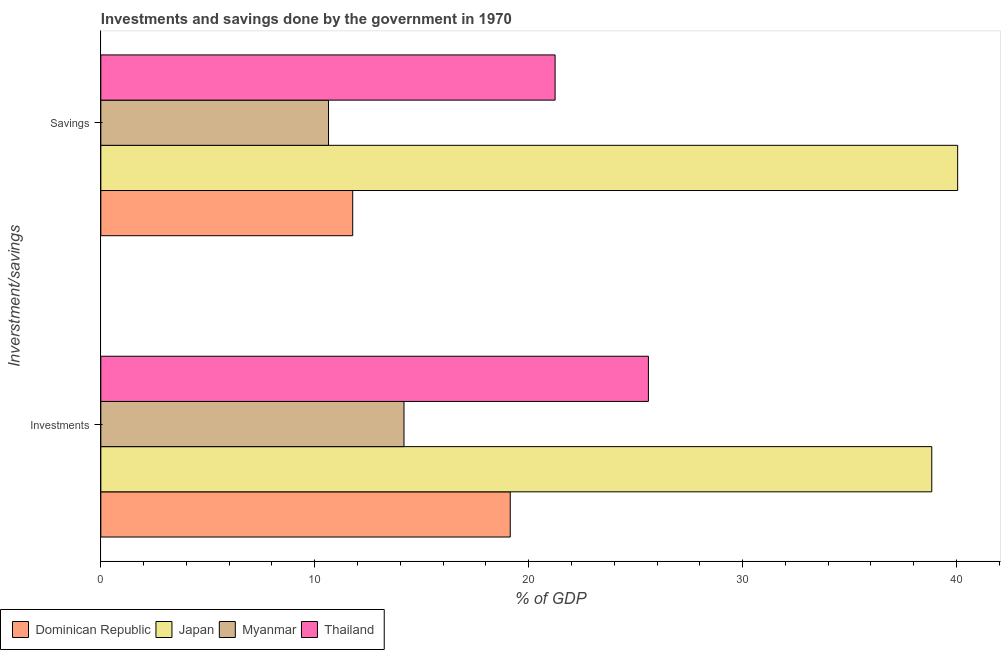How many different coloured bars are there?
Your response must be concise. 4. Are the number of bars on each tick of the Y-axis equal?
Ensure brevity in your answer.  Yes. How many bars are there on the 2nd tick from the bottom?
Offer a very short reply. 4. What is the label of the 2nd group of bars from the top?
Offer a terse response. Investments. What is the investments of government in Thailand?
Offer a very short reply. 25.6. Across all countries, what is the maximum investments of government?
Your answer should be compact. 38.84. Across all countries, what is the minimum investments of government?
Your answer should be compact. 14.17. In which country was the investments of government minimum?
Your answer should be compact. Myanmar. What is the total savings of government in the graph?
Give a very brief answer. 83.71. What is the difference between the investments of government in Japan and that in Myanmar?
Keep it short and to the point. 24.67. What is the difference between the savings of government in Myanmar and the investments of government in Dominican Republic?
Your answer should be compact. -8.5. What is the average savings of government per country?
Ensure brevity in your answer.  20.93. What is the difference between the savings of government and investments of government in Myanmar?
Provide a short and direct response. -3.53. In how many countries, is the savings of government greater than 12 %?
Give a very brief answer. 2. What is the ratio of the savings of government in Thailand to that in Japan?
Offer a terse response. 0.53. What does the 4th bar from the top in Investments represents?
Offer a terse response. Dominican Republic. What does the 3rd bar from the bottom in Investments represents?
Give a very brief answer. Myanmar. How many bars are there?
Provide a short and direct response. 8. Does the graph contain any zero values?
Your answer should be compact. No. How many legend labels are there?
Ensure brevity in your answer.  4. How are the legend labels stacked?
Make the answer very short. Horizontal. What is the title of the graph?
Offer a very short reply. Investments and savings done by the government in 1970. Does "Sao Tome and Principe" appear as one of the legend labels in the graph?
Your answer should be very brief. No. What is the label or title of the X-axis?
Your answer should be compact. % of GDP. What is the label or title of the Y-axis?
Your response must be concise. Inverstment/savings. What is the % of GDP of Dominican Republic in Investments?
Provide a short and direct response. 19.14. What is the % of GDP in Japan in Investments?
Offer a very short reply. 38.84. What is the % of GDP of Myanmar in Investments?
Provide a succinct answer. 14.17. What is the % of GDP in Thailand in Investments?
Offer a very short reply. 25.6. What is the % of GDP in Dominican Republic in Savings?
Make the answer very short. 11.77. What is the % of GDP of Japan in Savings?
Provide a succinct answer. 40.05. What is the % of GDP in Myanmar in Savings?
Your answer should be very brief. 10.64. What is the % of GDP of Thailand in Savings?
Provide a short and direct response. 21.24. Across all Inverstment/savings, what is the maximum % of GDP in Dominican Republic?
Ensure brevity in your answer.  19.14. Across all Inverstment/savings, what is the maximum % of GDP of Japan?
Ensure brevity in your answer.  40.05. Across all Inverstment/savings, what is the maximum % of GDP of Myanmar?
Give a very brief answer. 14.17. Across all Inverstment/savings, what is the maximum % of GDP of Thailand?
Ensure brevity in your answer.  25.6. Across all Inverstment/savings, what is the minimum % of GDP in Dominican Republic?
Your response must be concise. 11.77. Across all Inverstment/savings, what is the minimum % of GDP in Japan?
Ensure brevity in your answer.  38.84. Across all Inverstment/savings, what is the minimum % of GDP in Myanmar?
Provide a succinct answer. 10.64. Across all Inverstment/savings, what is the minimum % of GDP of Thailand?
Provide a succinct answer. 21.24. What is the total % of GDP of Dominican Republic in the graph?
Make the answer very short. 30.91. What is the total % of GDP in Japan in the graph?
Give a very brief answer. 78.9. What is the total % of GDP of Myanmar in the graph?
Your answer should be very brief. 24.81. What is the total % of GDP in Thailand in the graph?
Give a very brief answer. 46.83. What is the difference between the % of GDP in Dominican Republic in Investments and that in Savings?
Provide a succinct answer. 7.37. What is the difference between the % of GDP in Japan in Investments and that in Savings?
Your answer should be compact. -1.21. What is the difference between the % of GDP of Myanmar in Investments and that in Savings?
Give a very brief answer. 3.53. What is the difference between the % of GDP of Thailand in Investments and that in Savings?
Your answer should be compact. 4.36. What is the difference between the % of GDP in Dominican Republic in Investments and the % of GDP in Japan in Savings?
Your answer should be compact. -20.92. What is the difference between the % of GDP of Dominican Republic in Investments and the % of GDP of Myanmar in Savings?
Keep it short and to the point. 8.5. What is the difference between the % of GDP in Dominican Republic in Investments and the % of GDP in Thailand in Savings?
Ensure brevity in your answer.  -2.1. What is the difference between the % of GDP of Japan in Investments and the % of GDP of Myanmar in Savings?
Your answer should be very brief. 28.2. What is the difference between the % of GDP in Japan in Investments and the % of GDP in Thailand in Savings?
Your answer should be compact. 17.61. What is the difference between the % of GDP of Myanmar in Investments and the % of GDP of Thailand in Savings?
Your response must be concise. -7.06. What is the average % of GDP in Dominican Republic per Inverstment/savings?
Offer a terse response. 15.46. What is the average % of GDP of Japan per Inverstment/savings?
Keep it short and to the point. 39.45. What is the average % of GDP of Myanmar per Inverstment/savings?
Offer a very short reply. 12.41. What is the average % of GDP in Thailand per Inverstment/savings?
Your answer should be compact. 23.42. What is the difference between the % of GDP in Dominican Republic and % of GDP in Japan in Investments?
Keep it short and to the point. -19.7. What is the difference between the % of GDP of Dominican Republic and % of GDP of Myanmar in Investments?
Your response must be concise. 4.97. What is the difference between the % of GDP of Dominican Republic and % of GDP of Thailand in Investments?
Offer a terse response. -6.46. What is the difference between the % of GDP of Japan and % of GDP of Myanmar in Investments?
Ensure brevity in your answer.  24.67. What is the difference between the % of GDP of Japan and % of GDP of Thailand in Investments?
Offer a terse response. 13.25. What is the difference between the % of GDP of Myanmar and % of GDP of Thailand in Investments?
Your answer should be very brief. -11.43. What is the difference between the % of GDP of Dominican Republic and % of GDP of Japan in Savings?
Give a very brief answer. -28.28. What is the difference between the % of GDP of Dominican Republic and % of GDP of Myanmar in Savings?
Ensure brevity in your answer.  1.13. What is the difference between the % of GDP in Dominican Republic and % of GDP in Thailand in Savings?
Your response must be concise. -9.46. What is the difference between the % of GDP in Japan and % of GDP in Myanmar in Savings?
Keep it short and to the point. 29.41. What is the difference between the % of GDP of Japan and % of GDP of Thailand in Savings?
Ensure brevity in your answer.  18.82. What is the difference between the % of GDP of Myanmar and % of GDP of Thailand in Savings?
Your answer should be very brief. -10.59. What is the ratio of the % of GDP in Dominican Republic in Investments to that in Savings?
Provide a short and direct response. 1.63. What is the ratio of the % of GDP in Japan in Investments to that in Savings?
Provide a succinct answer. 0.97. What is the ratio of the % of GDP of Myanmar in Investments to that in Savings?
Offer a very short reply. 1.33. What is the ratio of the % of GDP of Thailand in Investments to that in Savings?
Make the answer very short. 1.21. What is the difference between the highest and the second highest % of GDP of Dominican Republic?
Your answer should be very brief. 7.37. What is the difference between the highest and the second highest % of GDP of Japan?
Ensure brevity in your answer.  1.21. What is the difference between the highest and the second highest % of GDP in Myanmar?
Your answer should be compact. 3.53. What is the difference between the highest and the second highest % of GDP of Thailand?
Offer a terse response. 4.36. What is the difference between the highest and the lowest % of GDP in Dominican Republic?
Your answer should be compact. 7.37. What is the difference between the highest and the lowest % of GDP in Japan?
Provide a short and direct response. 1.21. What is the difference between the highest and the lowest % of GDP in Myanmar?
Offer a terse response. 3.53. What is the difference between the highest and the lowest % of GDP in Thailand?
Your answer should be very brief. 4.36. 